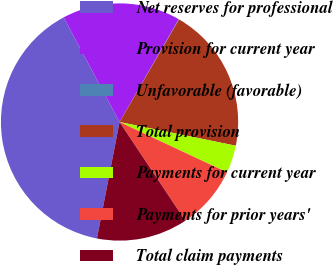<chart> <loc_0><loc_0><loc_500><loc_500><pie_chart><fcel>Net reserves for professional<fcel>Provision for current year<fcel>Unfavorable (favorable)<fcel>Total provision<fcel>Payments for current year<fcel>Payments for prior years'<fcel>Total claim payments<nl><fcel>39.15%<fcel>16.12%<fcel>0.05%<fcel>19.84%<fcel>3.77%<fcel>8.68%<fcel>12.4%<nl></chart> 